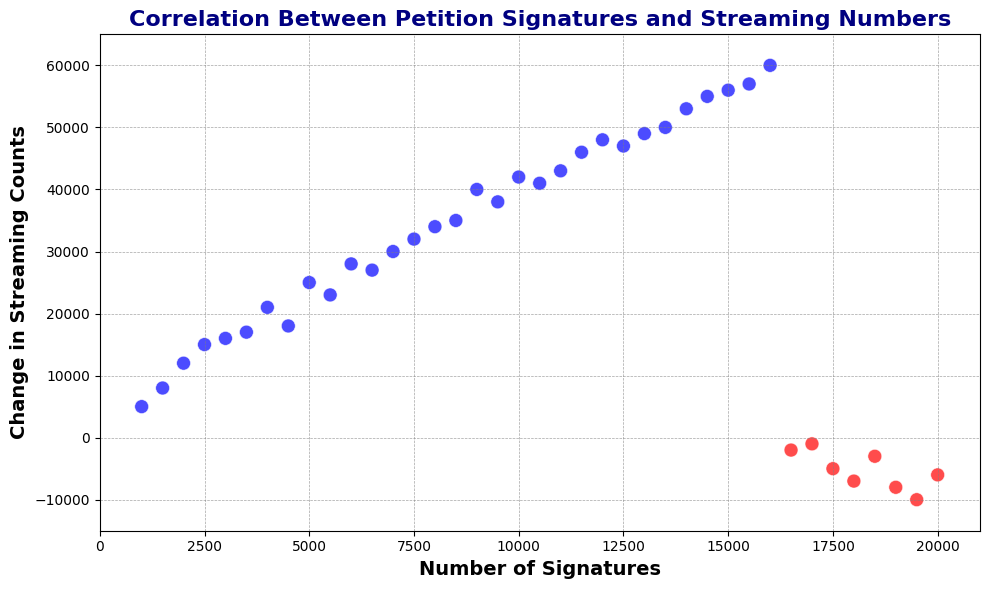How many data points are there in total? Count the number of points visually represented on the scatter plot.
Answer: 40 Which color represents positive changes in streaming counts? Identify the color that corresponds to positive changes.
Answer: Blue At approximately how many signatures do we start seeing a negative change in streaming counts? Look for the X-axis value where the color changes from blue to red.
Answer: 16,500 signatures What is the range of change in streaming counts for positive values? Identify the highest and lowest positive values on the Y-axis for blue points. The range is the difference between these values.
Answer: 5,000 to 60,000 Which data point has the highest positive change in streaming counts? Find the blue point with the highest Y-axis value.
Answer: 60,000 Which signature count value corresponds to the lowest negative change in streaming numbers? Locate the red point with the lowest Y-axis value and find its X-axis value.
Answer: 19,000 signatures What is the total change in streaming counts summed for all positive changes? Sum all positive Y-axis values from the plot.
Answer: 573,000 What's the average change in streaming counts for signature counts between 10,000 and 15,000? Find the points where 10,000 <= X <= 15,000, sum their Y values, and divide by the number of points.
Answer: 45,000 Which point represents the maximum negative change in streaming counts, and what is that value? Locate the red point with the highest negative Y-axis value.
Answer: -10,000 Which has a greater change in streaming counts: 8,000 or 18,000 signature counts? Compare the Y-axis values for these two X-axis signature values.
Answer: 8,000 signatures 